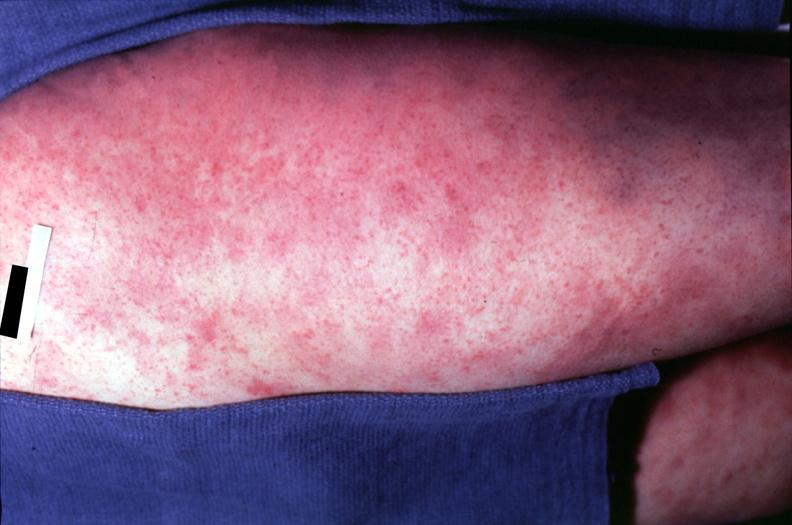s anencephaly and bilateral cleft palate spotted fever, morbilliform rash?
Answer the question using a single word or phrase. No 